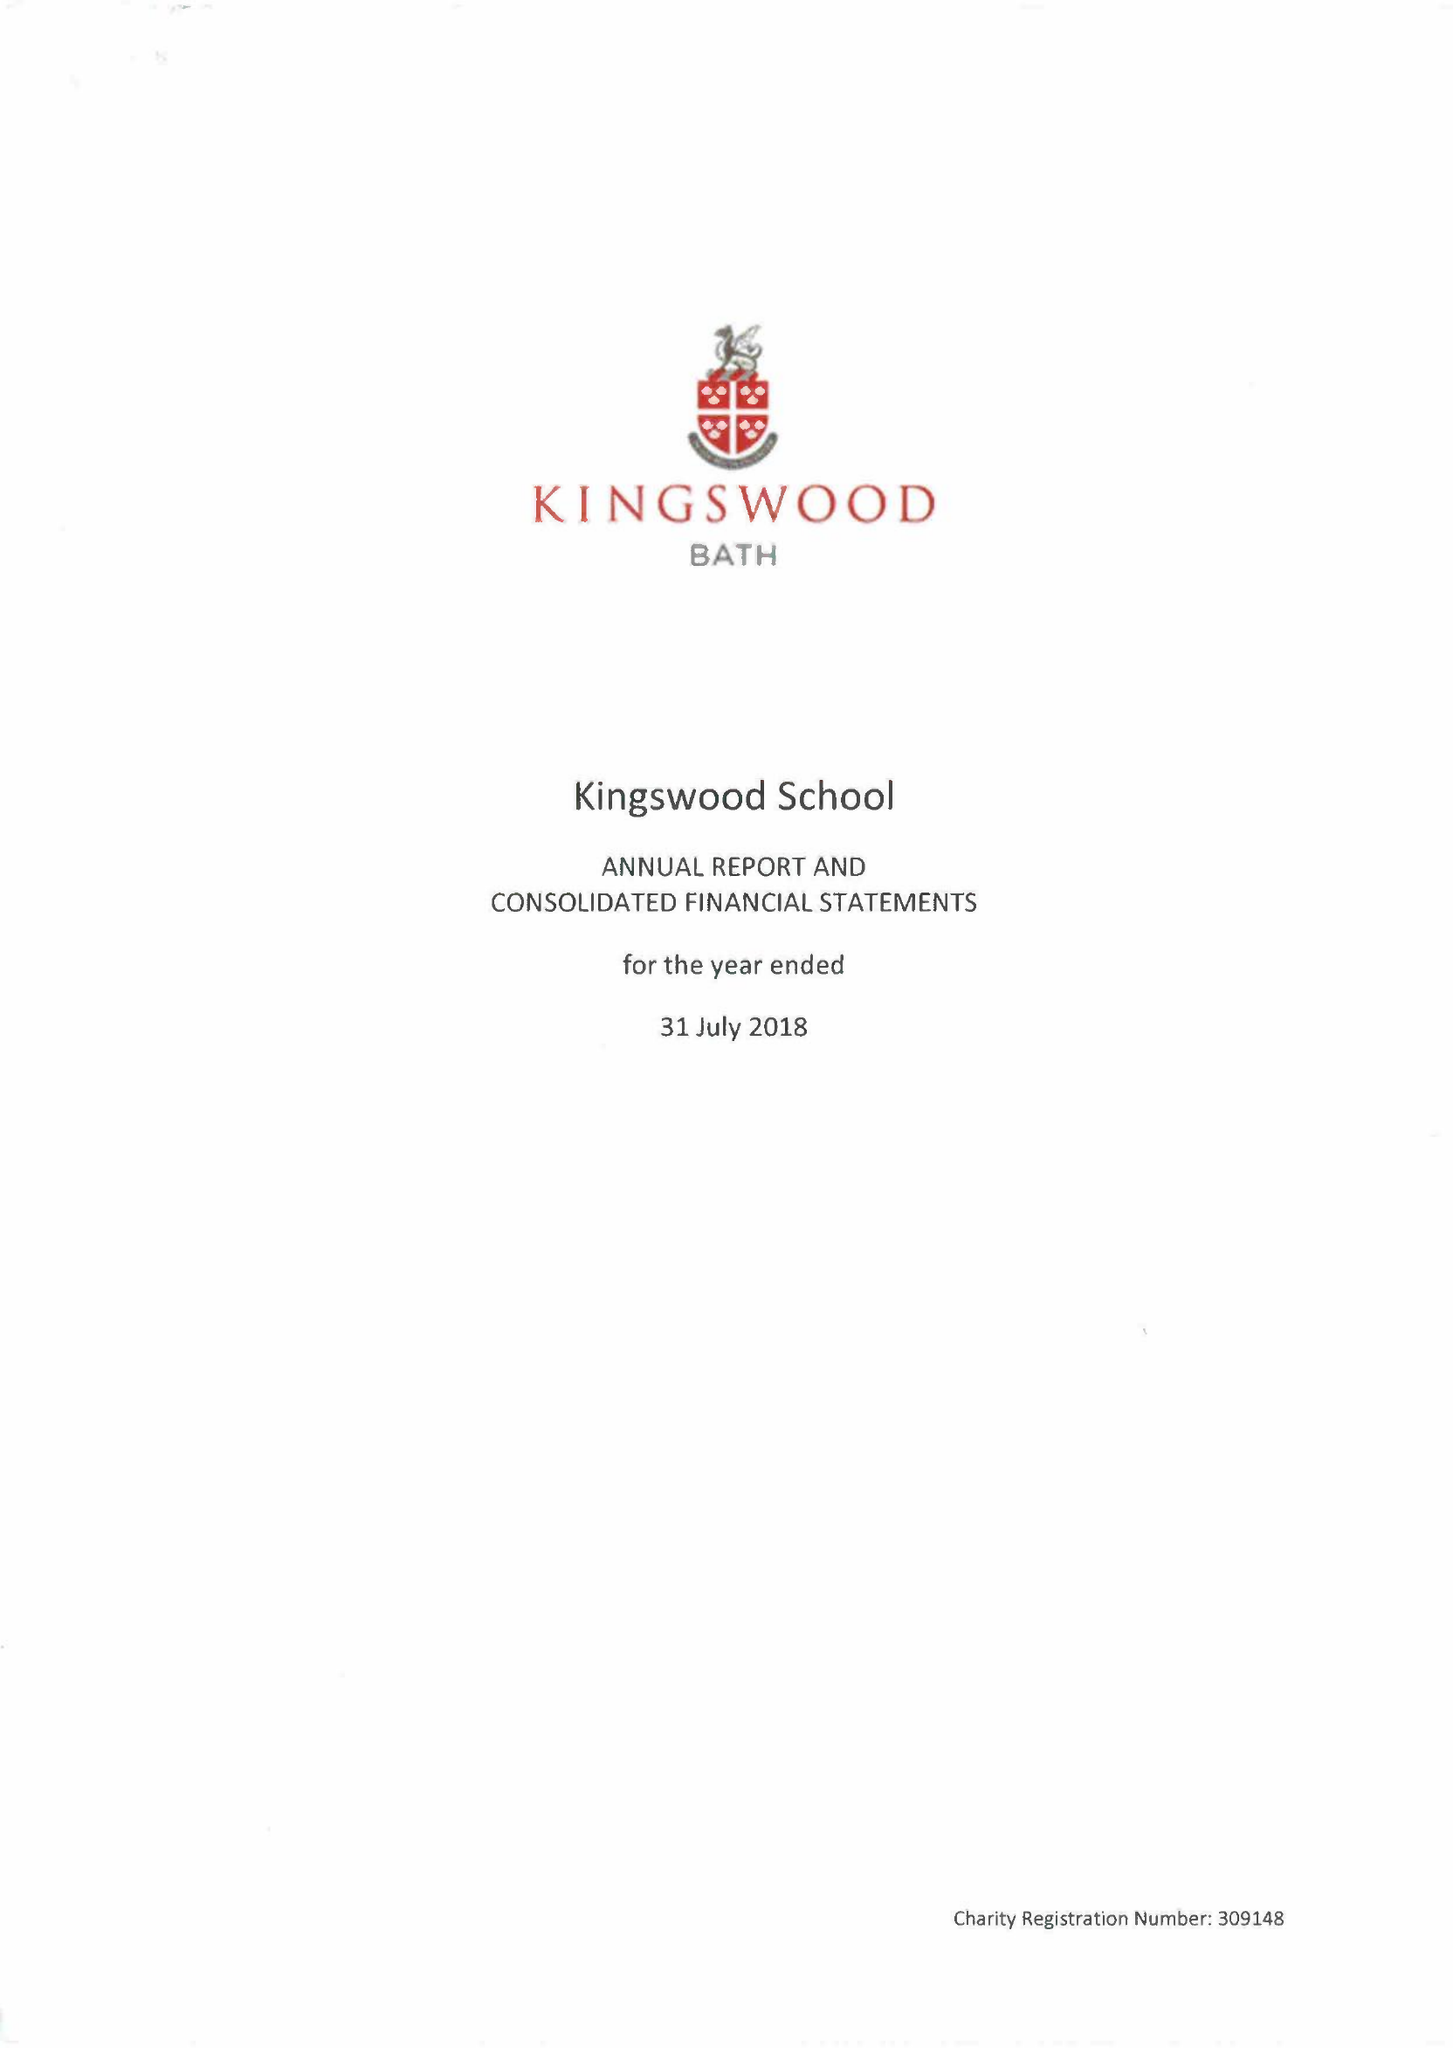What is the value for the charity_name?
Answer the question using a single word or phrase. Kingswood School 